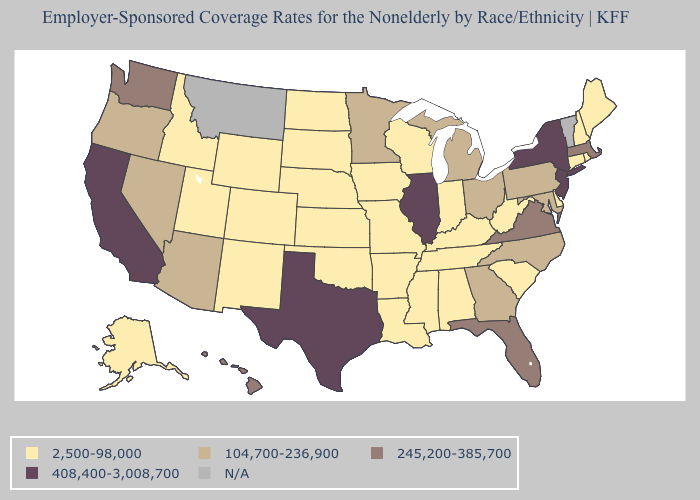Does Nebraska have the highest value in the MidWest?
Give a very brief answer. No. What is the value of Virginia?
Short answer required. 245,200-385,700. What is the highest value in the Northeast ?
Concise answer only. 408,400-3,008,700. Name the states that have a value in the range N/A?
Keep it brief. Montana, Vermont. Does Minnesota have the highest value in the MidWest?
Keep it brief. No. Name the states that have a value in the range 104,700-236,900?
Answer briefly. Arizona, Georgia, Maryland, Michigan, Minnesota, Nevada, North Carolina, Ohio, Oregon, Pennsylvania. Which states hav the highest value in the MidWest?
Be succinct. Illinois. Does the first symbol in the legend represent the smallest category?
Answer briefly. Yes. Does New York have the lowest value in the Northeast?
Concise answer only. No. What is the value of Minnesota?
Quick response, please. 104,700-236,900. Name the states that have a value in the range 245,200-385,700?
Short answer required. Florida, Hawaii, Massachusetts, Virginia, Washington. Is the legend a continuous bar?
Give a very brief answer. No. What is the value of Utah?
Concise answer only. 2,500-98,000. 